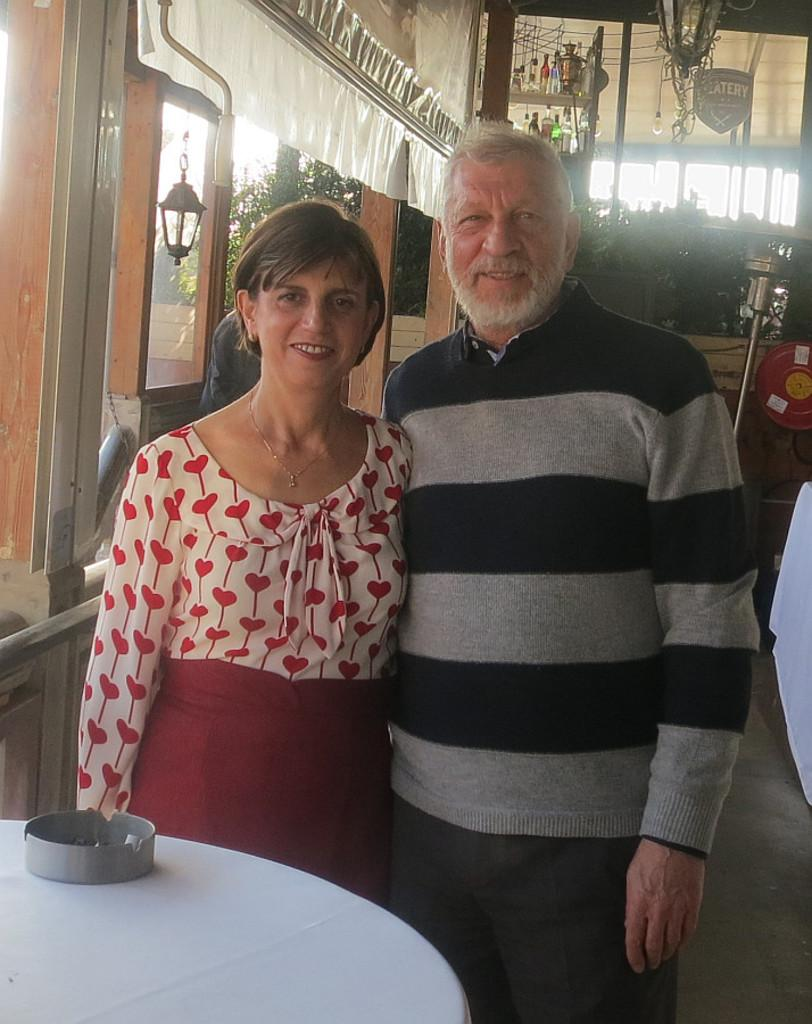Who is present in the image? There is a couple in the image. Where are the couple positioned in the image? The couple is standing at the center of the image. What is the couple's facial expression in the image? The couple is smiling. What type of insurance policy is the couple discussing in the image? There is no indication in the image that the couple is discussing any insurance policies. 